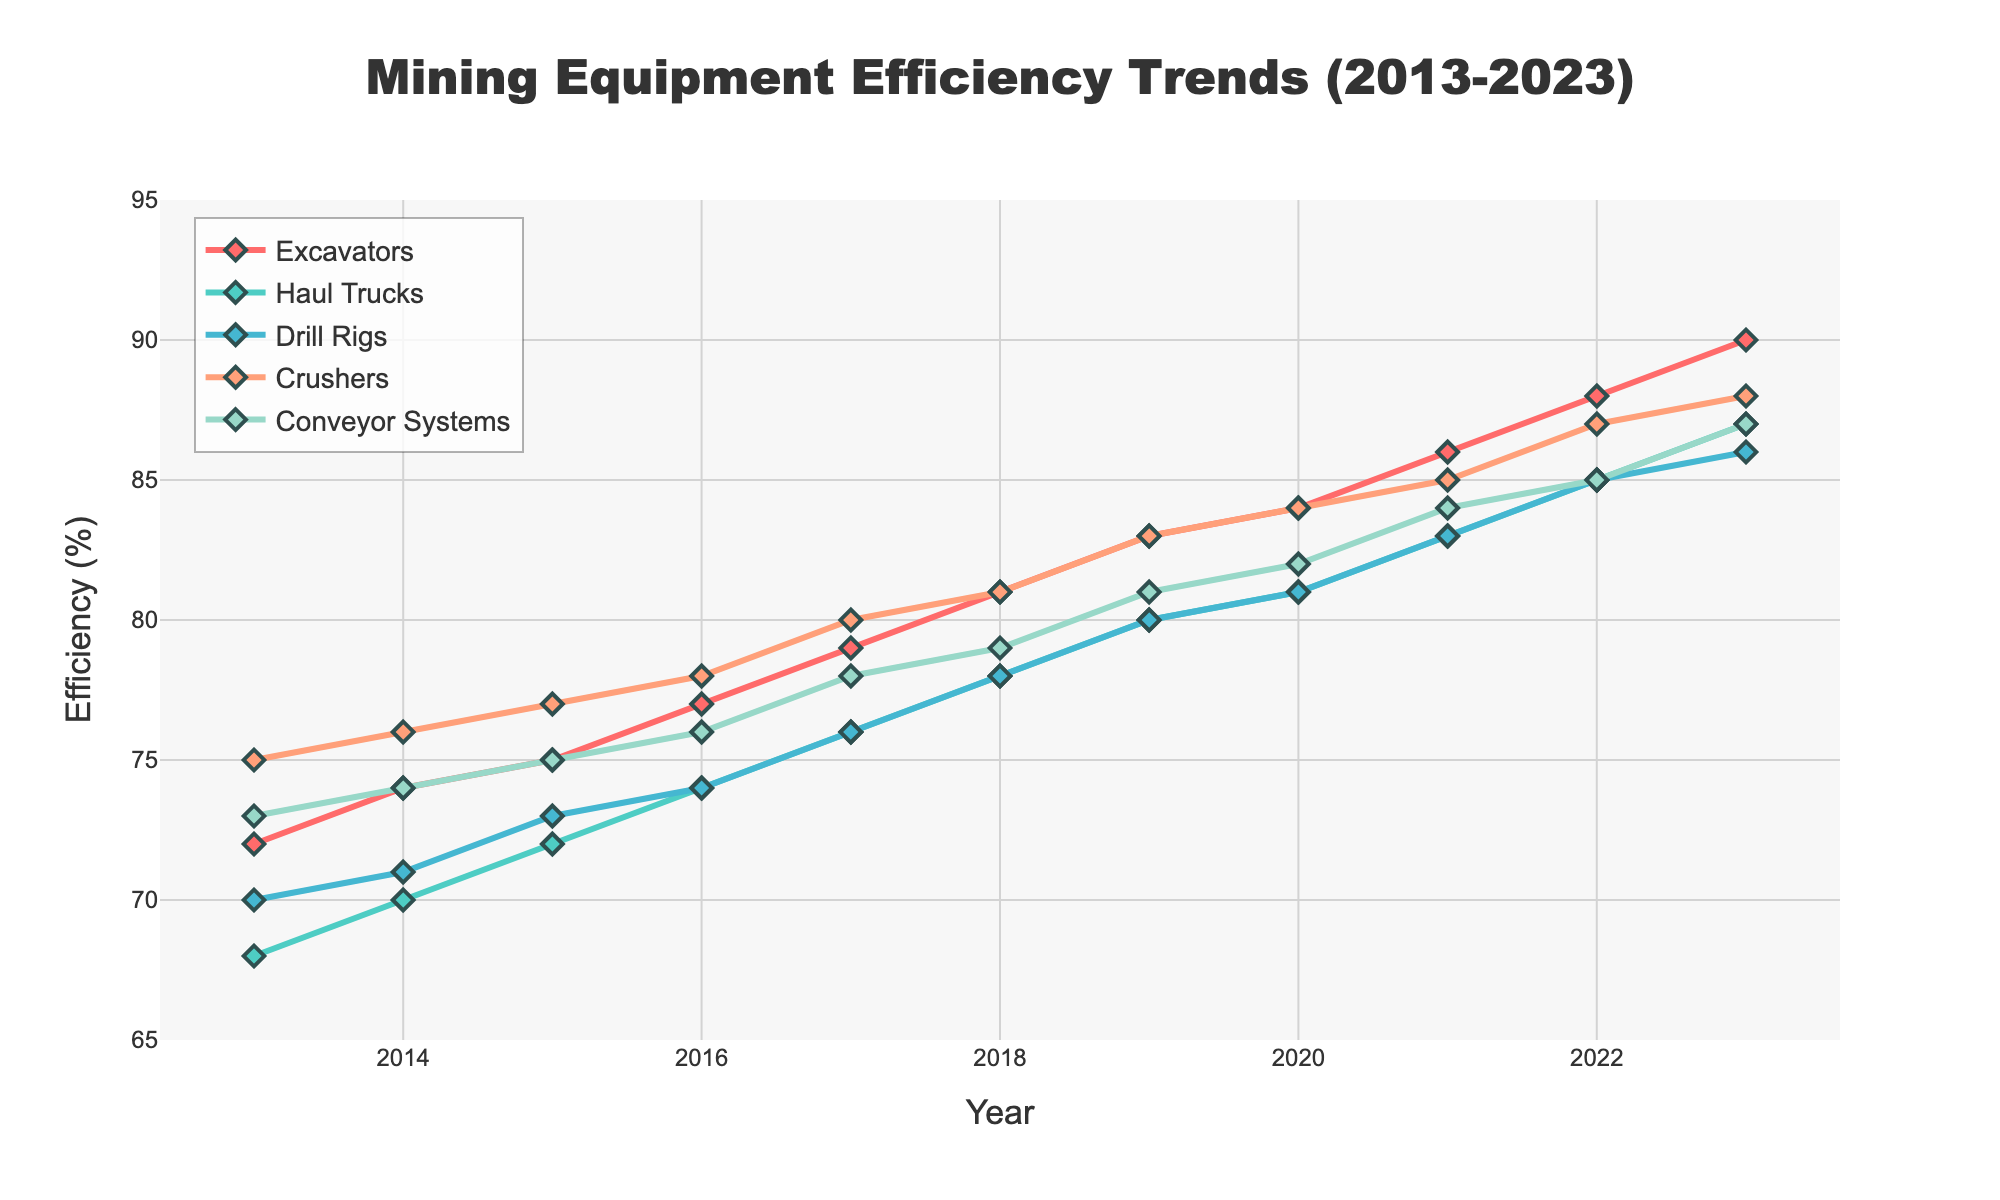What's the general trend in the efficiency of Conveyor Systems from 2013 to 2023? The efficiency of Conveyor Systems has shown a consistent upward trend over the years, starting at 73% in 2013 and reaching 87% in 2023. This indicates a steady improvement in the efficiency of Conveyor Systems over the decade.
Answer: Upward trend Which machine type had the highest efficiency in 2023? By looking at the efficiency values in 2023, Excavators had the highest efficiency at 90%.
Answer: Excavators In which year did the efficiency of Drill Rigs first surpass 80%? By examining the trend of Drill Rigs, we see that in 2019 the efficiency reached 80% for the first time, surpassing this threshold in 2020 with an efficiency of 81%.
Answer: 2020 What is the average efficiency of Haul Trucks from 2013 to 2023? The efficiencies for Haul Trucks are: 68, 70, 72, 74, 76, 78, 80, 81, 83, 85, and 87. Summing these values gives 854, and there are 11 years in total. Dividing the sum by the number of years gives 854/11 ≈ 77.64.
Answer: 77.64 Which year saw the biggest increase in the efficiency of Excavators? Comparing the yearly differences, the increase in efficiency for Excavators from 2022 to 2023 is 2% (88% to 90%), which is the largest single-year increase.
Answer: 2022-2023 How does the efficiency of Crushers in 2017 compare to that in 2013? In 2017, the efficiency of Crushers was 80%, whereas in 2013 it was 75%. The increase is 80% - 75% = 5%.
Answer: 5% increase Which equipment type showed the most consistent improvement over the years? Examining the trends, Excavators showed a consistent increase in efficiency each year from 72% in 2013 to 90% in 2023 without any noticeable drops or plateaus.
Answer: Excavators What was the total increase in efficiency for Drill Rigs from 2013 to 2023? The efficiency of Drill Rigs in 2013 was 70%, and in 2023 it was 86%. Therefore, the total increase over this period is 86% - 70% = 16%.
Answer: 16% 